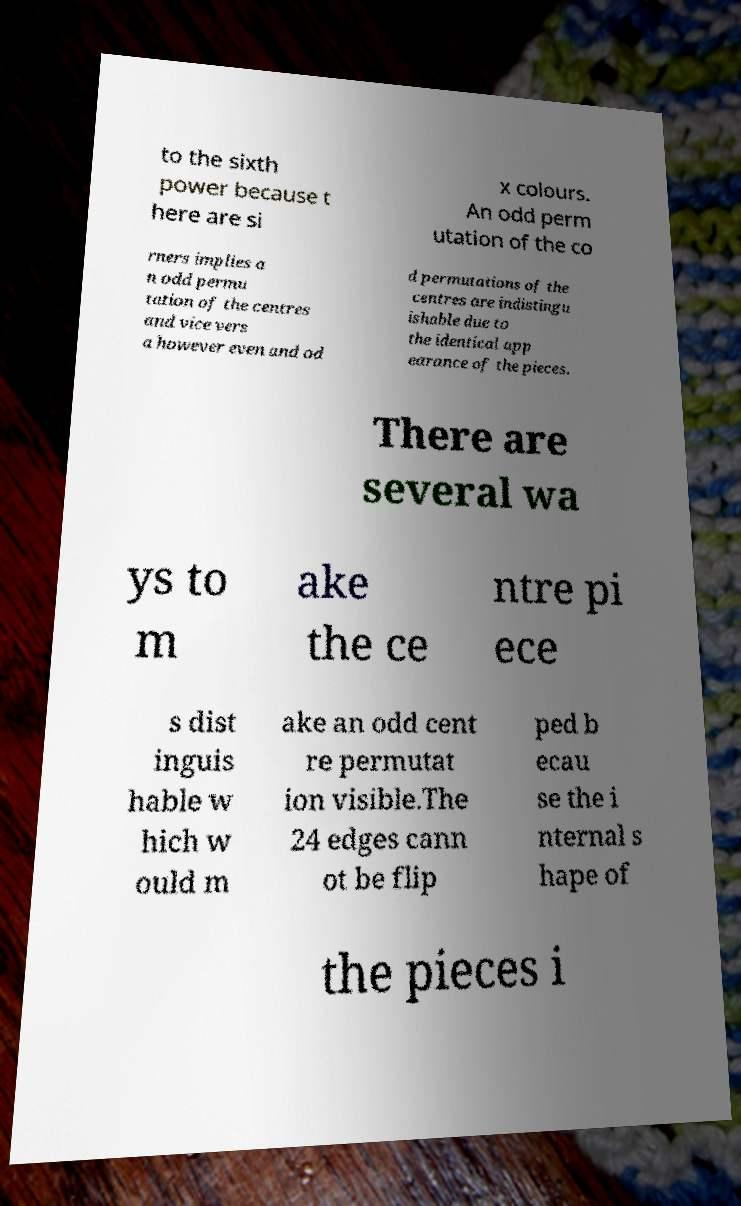Can you accurately transcribe the text from the provided image for me? to the sixth power because t here are si x colours. An odd perm utation of the co rners implies a n odd permu tation of the centres and vice vers a however even and od d permutations of the centres are indistingu ishable due to the identical app earance of the pieces. There are several wa ys to m ake the ce ntre pi ece s dist inguis hable w hich w ould m ake an odd cent re permutat ion visible.The 24 edges cann ot be flip ped b ecau se the i nternal s hape of the pieces i 